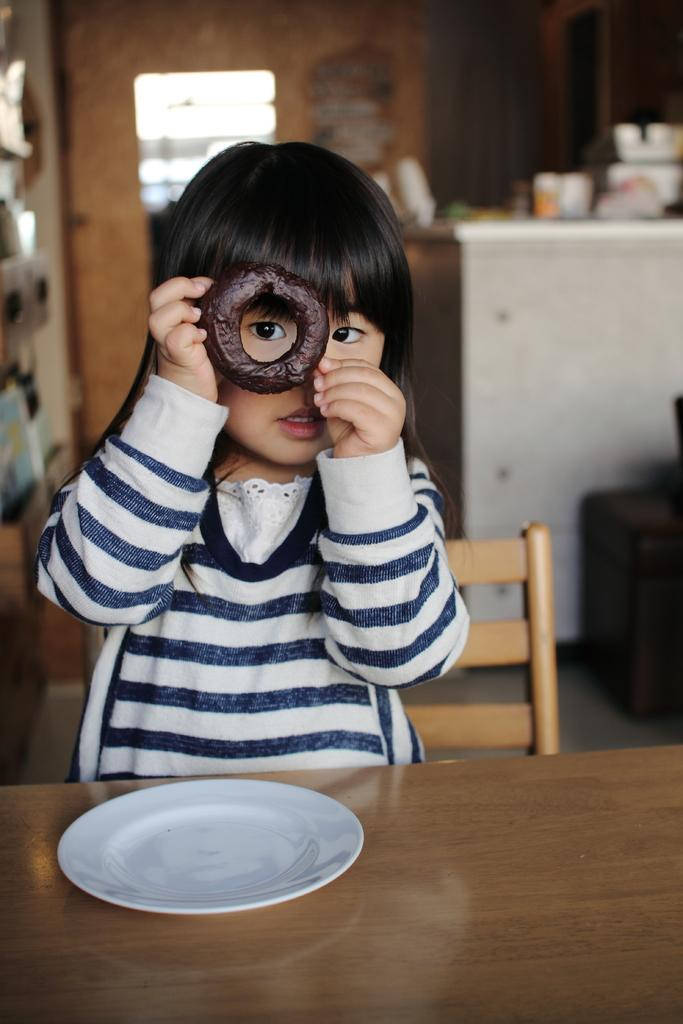What is on the table in the image? There is a plate on the table in the image. What is the girl in the image doing? The girl is sitting on a chair in the image. What is the girl holding in her hand? The girl is holding a donut in her hand. Is the girl sinking into quicksand in the image? No, there is no quicksand present in the image. Does the girl in the image have any supernatural powers that allow her to believe in the impossible? The image does not provide any information about the girl's beliefs or supernatural abilities. 